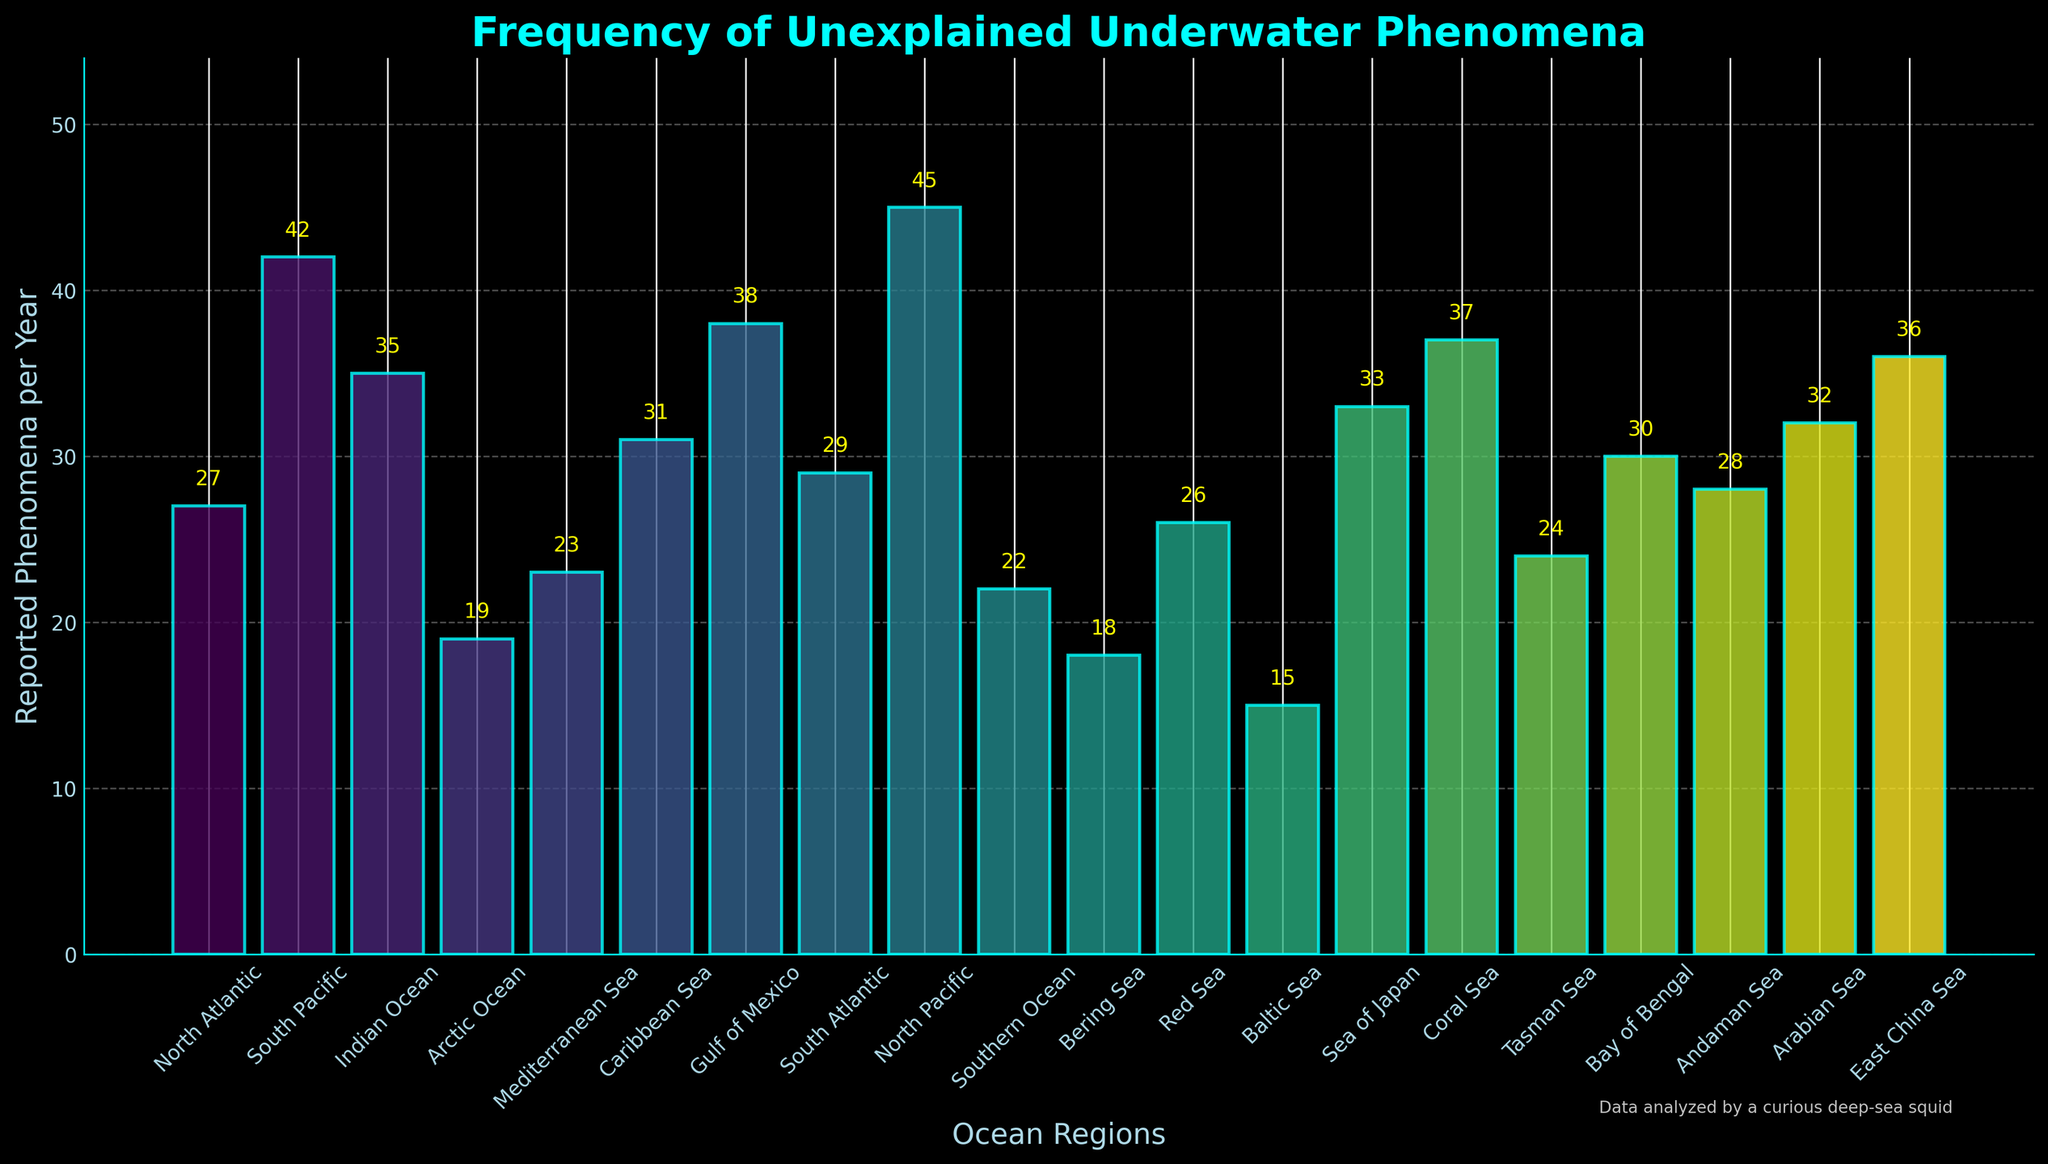Which region reported the highest frequency of unexplained underwater phenomena? The North Pacific reported the highest frequency as determined by the tallest bar in the plot representing 45 phenomena.
Answer: North Pacific What is the difference in the number of unexplained phenomena between the South Pacific and the North Atlantic? The South Pacific reported 42 phenomena and the North Atlantic reported 27. The difference is 42 - 27 = 15.
Answer: 15 Which ocean regions have more than 35 reported phenomena? The regions with more than 35 reported phenomena can be identified from the bars higher than the 35 mark: South Pacific (42), Gulf of Mexico (38), North Pacific (45), Coral Sea (37), East China Sea (36).
Answer: South Pacific, Gulf of Mexico, North Pacific, Coral Sea, East China Sea Is the frequency of reported phenomena in the Arabian Sea greater than in the Sea of Japan? Comparing the heights of the bars, the Arabian Sea has 32, while the Sea of Japan has 33, so the Sea of Japan has a slightly higher frequency.
Answer: No What is the average number of unexplained phenomena reported per year across all regions? Sum all the reported phenomena: 27 + 42 + 35 + 19 + 23 + 31 + 38 + 29 + 45 + 22 + 18 + 26 + 15 + 33 + 37 + 24 + 30 + 28 + 32 + 36 = 590. There are 20 regions, so the average is 590 / 20 = 29.5.
Answer: 29.5 Which region reported the least frequency of unexplained phenomena? The region with the shortest bar represents the least frequency, which is the Baltic Sea with 15 phenomena.
Answer: Baltic Sea What is the combined total of unexplained phenomena in the Caribbean Sea and the Red Sea? The Caribbean Sea reported 31 and the Red Sea reported 26; their combined total is 31 + 26 = 57.
Answer: 57 How many regions reported fewer than 25 unexplained phenomena per year? Regions with fewer than 25 phenomena can be identified by bars shorter than the 25 mark: Arctic Ocean (19), Bering Sea (18), Red Sea (26 is not less than 25), Baltic Sea (15). Therefore, the number is 4.
Answer: 4 How does the frequency of phenomena reported in the Mediterranean Sea compare to that in the Southern Ocean? The Mediterranean Sea reported 23 phenomena, and the Southern Ocean reported 22. The Mediterranean Sea reported slightly more phenomena.
Answer: Higher by 1 What is the median number of unexplained phenomena reported per year across all regions? List the reported phenomena in ascending order: 15, 18, 19, 22, 23, 24, 26, 27, 28, 29, 30, 31, 32, 33, 35, 36, 37, 38, 42, 45. There are 20 data points, so the median is the average of the 10th and 11th values: (29 + 30) / 2 = 29.5.
Answer: 29.5 